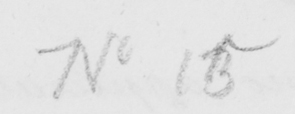What text is written in this handwritten line? No 15 